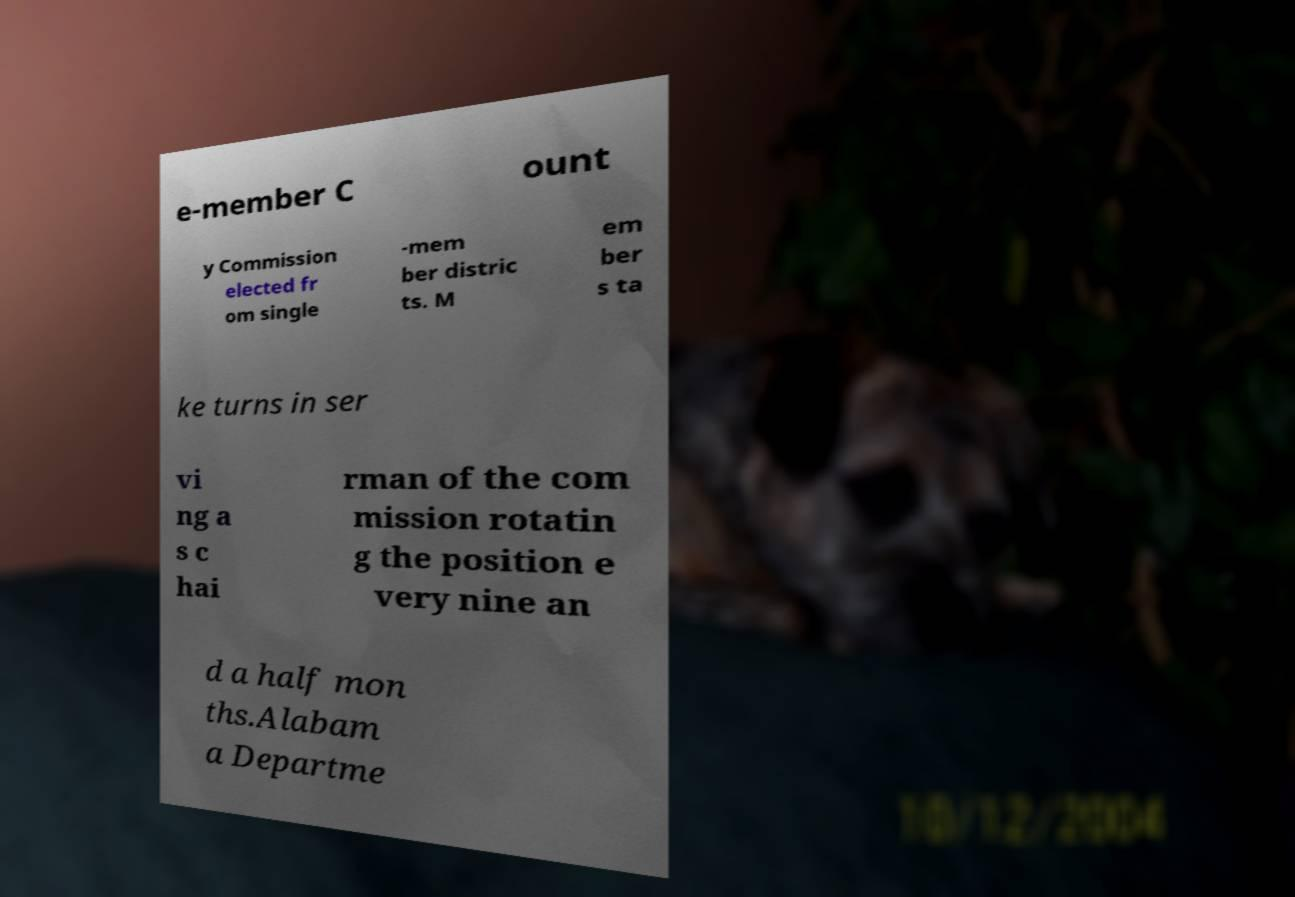Could you assist in decoding the text presented in this image and type it out clearly? e-member C ount y Commission elected fr om single -mem ber distric ts. M em ber s ta ke turns in ser vi ng a s c hai rman of the com mission rotatin g the position e very nine an d a half mon ths.Alabam a Departme 